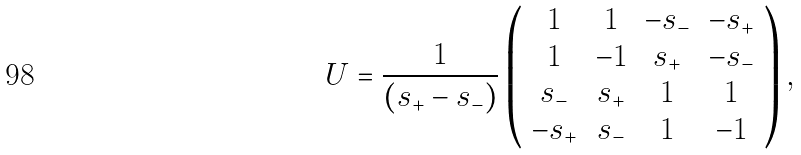<formula> <loc_0><loc_0><loc_500><loc_500>U = \frac { 1 } { \left ( s _ { + } - s _ { - } \right ) } \left ( \begin{array} { c c c c } 1 & 1 & - s _ { - } & - s _ { + } \\ 1 & - 1 & s _ { + } & - s _ { - } \\ s _ { - } & s _ { + } & 1 & 1 \\ - s _ { + } & s _ { - } & 1 & - 1 \\ \end{array} \right ) ,</formula> 